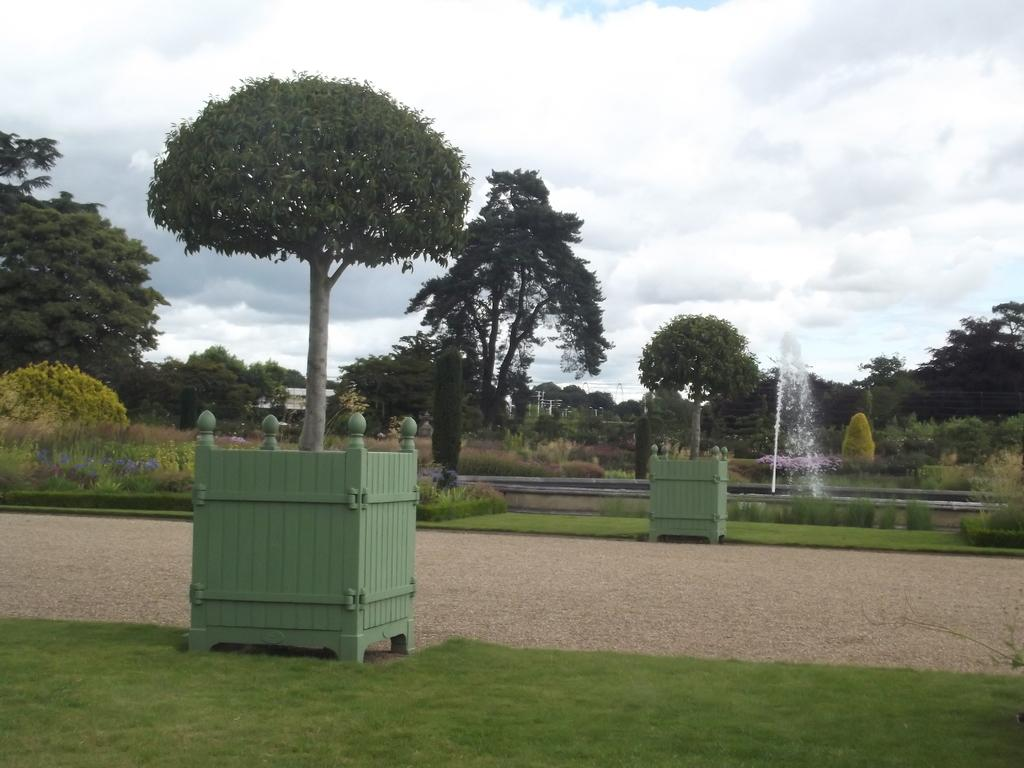What type of vegetation can be seen in the image? There is grass, plants, trees, and flowers visible in the image. What natural element is present in the image? There is water visible in the image. What color are the objects in the image? There are green objects in the image. What is visible in the background of the image? The sky is visible in the background of the image. What can be seen in the sky? There are clouds in the sky. How many necks can be seen on the snakes in the image? There are no snakes present in the image, so it is not possible to determine the number of necks. What type of metal is visible in the image? There is no metal, including zinc, present in the image. 